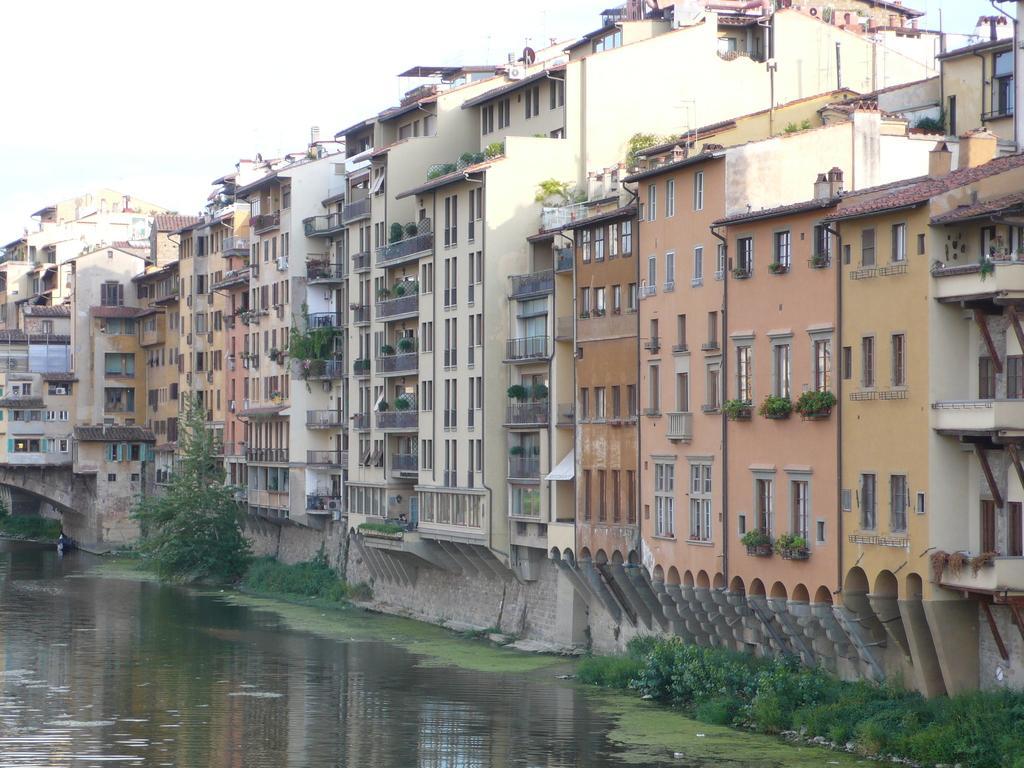Describe this image in one or two sentences. In this picture I can see the water in front and I can see few plants. In the background I can see number of buildings. 